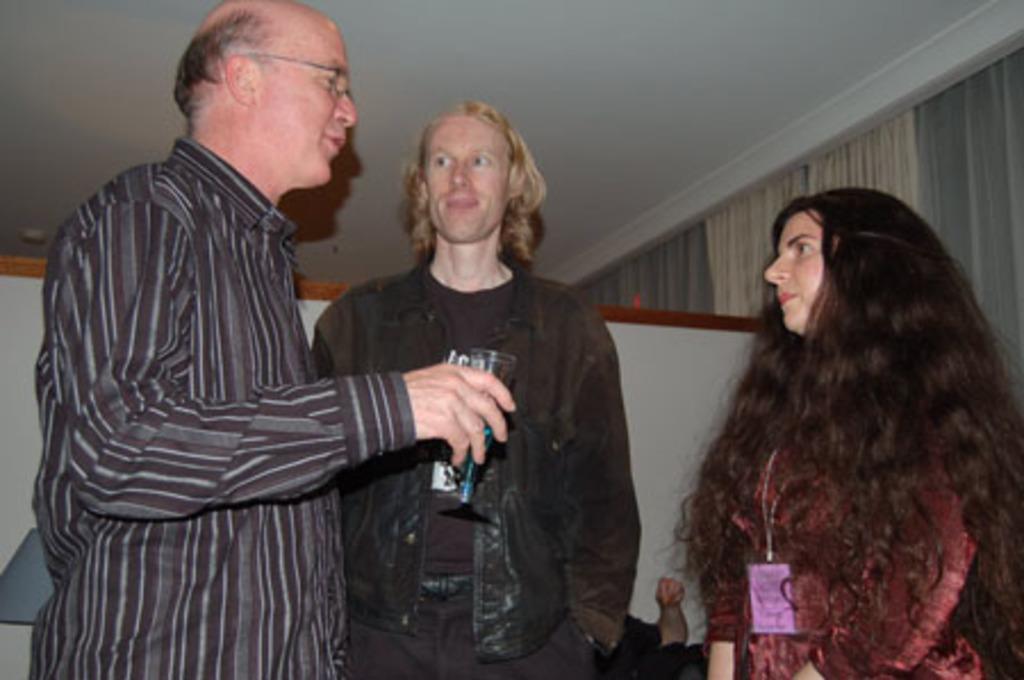Can you describe this image briefly? There are two men and the woman standing. They were talking to each other. In the background, that looks like a lamp shade. I can see a person's hand. These are the curtains hanging to the hanger. Here is the roof. 